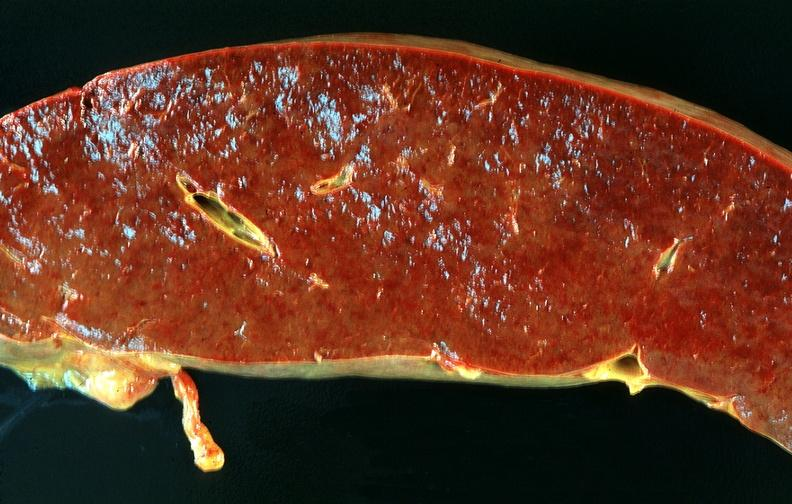s hematologic present?
Answer the question using a single word or phrase. Yes 